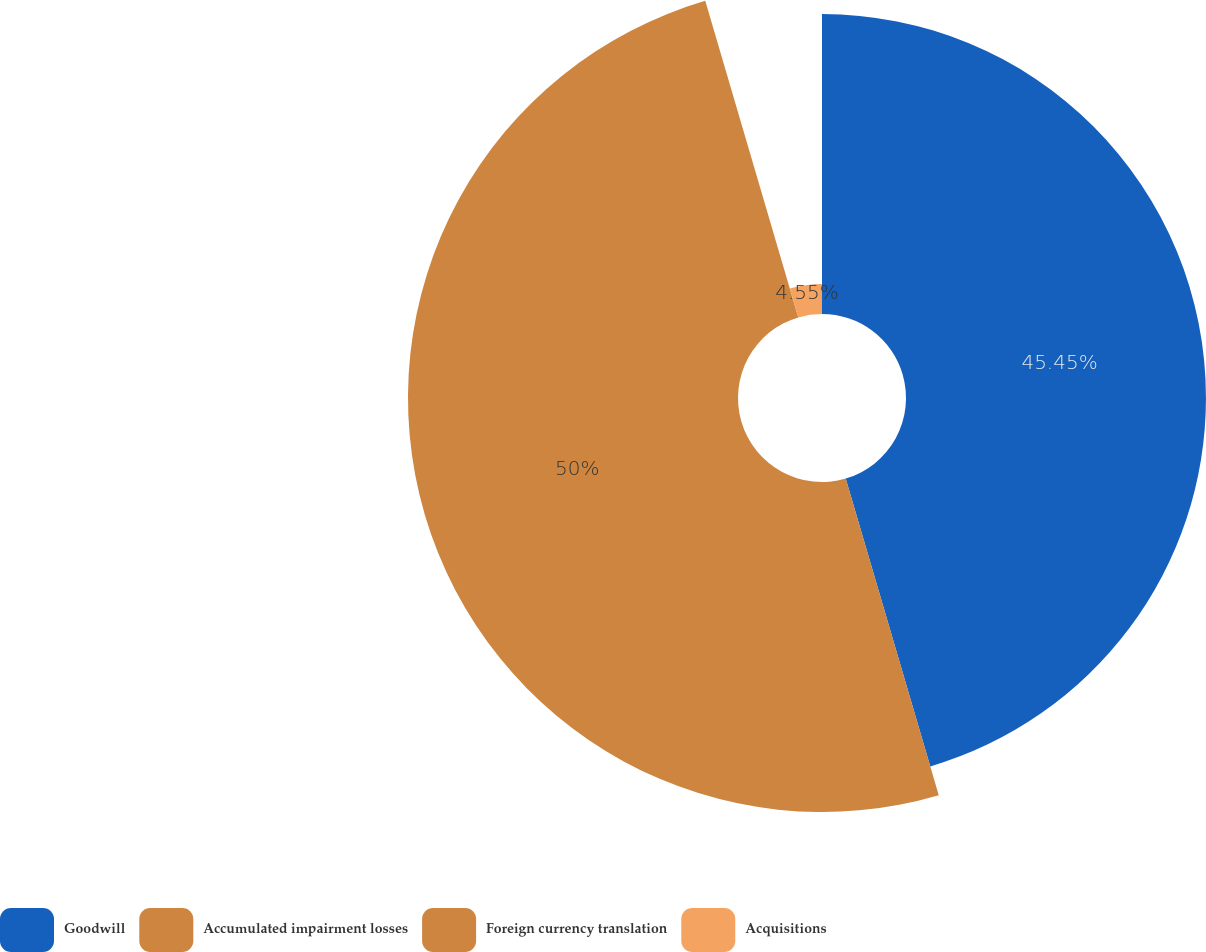Convert chart to OTSL. <chart><loc_0><loc_0><loc_500><loc_500><pie_chart><fcel>Goodwill<fcel>Accumulated impairment losses<fcel>Foreign currency translation<fcel>Acquisitions<nl><fcel>45.45%<fcel>50.0%<fcel>0.0%<fcel>4.55%<nl></chart> 